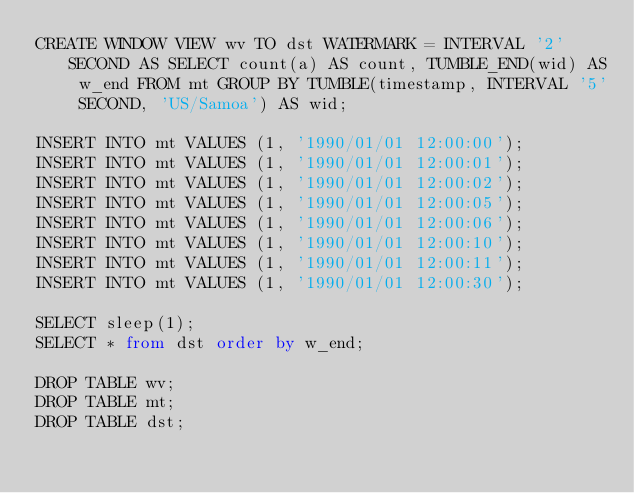<code> <loc_0><loc_0><loc_500><loc_500><_SQL_>CREATE WINDOW VIEW wv TO dst WATERMARK = INTERVAL '2' SECOND AS SELECT count(a) AS count, TUMBLE_END(wid) AS w_end FROM mt GROUP BY TUMBLE(timestamp, INTERVAL '5' SECOND, 'US/Samoa') AS wid;

INSERT INTO mt VALUES (1, '1990/01/01 12:00:00');
INSERT INTO mt VALUES (1, '1990/01/01 12:00:01');
INSERT INTO mt VALUES (1, '1990/01/01 12:00:02');
INSERT INTO mt VALUES (1, '1990/01/01 12:00:05');
INSERT INTO mt VALUES (1, '1990/01/01 12:00:06');
INSERT INTO mt VALUES (1, '1990/01/01 12:00:10');
INSERT INTO mt VALUES (1, '1990/01/01 12:00:11');
INSERT INTO mt VALUES (1, '1990/01/01 12:00:30');

SELECT sleep(1);
SELECT * from dst order by w_end;

DROP TABLE wv;
DROP TABLE mt;
DROP TABLE dst;
</code> 